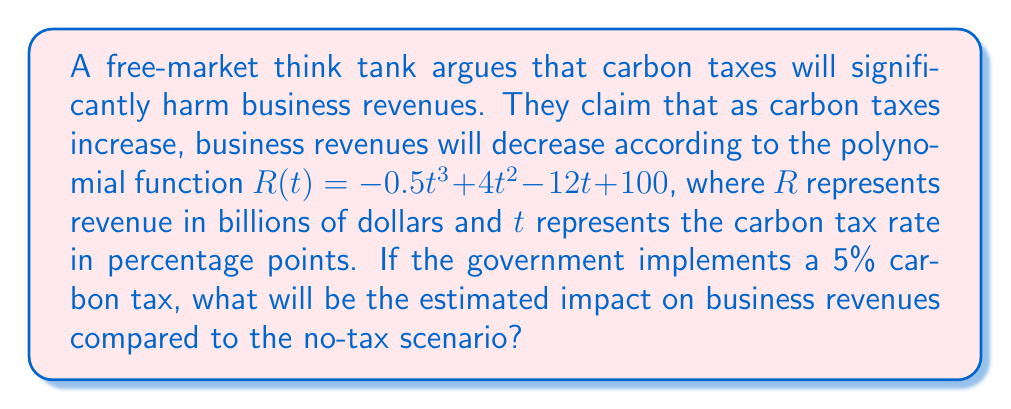What is the answer to this math problem? To solve this problem, we need to:

1. Calculate the revenue when there is no carbon tax $(t = 0)$
2. Calculate the revenue when there is a 5% carbon tax $(t = 5)$
3. Find the difference between these two values

Step 1: Revenue with no carbon tax $(t = 0)$
$$R(0) = -0.5(0)^3 + 4(0)^2 - 12(0) + 100 = 100$$

Step 2: Revenue with 5% carbon tax $(t = 5)$
$$\begin{aligned}
R(5) &= -0.5(5)^3 + 4(5)^2 - 12(5) + 100 \\
&= -0.5(125) + 4(25) - 12(5) + 100 \\
&= -62.5 + 100 - 60 + 100 \\
&= 77.5
\end{aligned}$$

Step 3: Impact on revenue
$$\text{Impact} = R(5) - R(0) = 77.5 - 100 = -22.5$$

The negative value indicates a decrease in revenue.
Answer: The estimated impact of a 5% carbon tax on business revenues is a decrease of $22.5 billion compared to the no-tax scenario. 